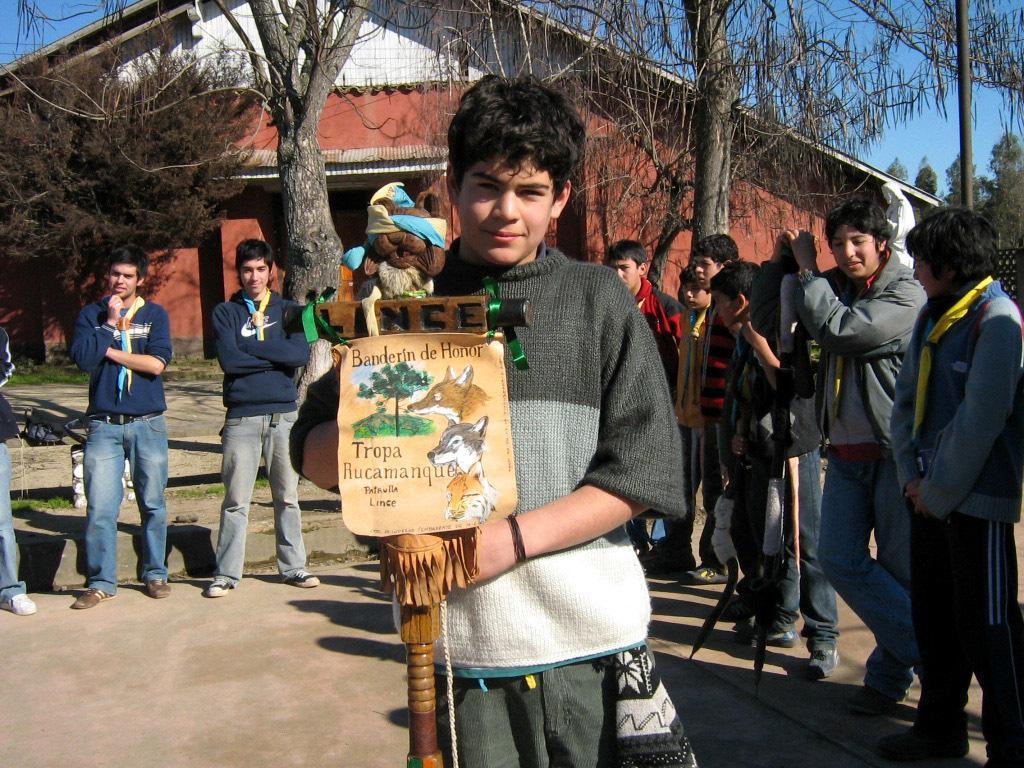Describe this image in one or two sentences. In this picture we can see a group of people standing on the ground, poster, toy, building, trees, some objects and in the background we can see the sky. 